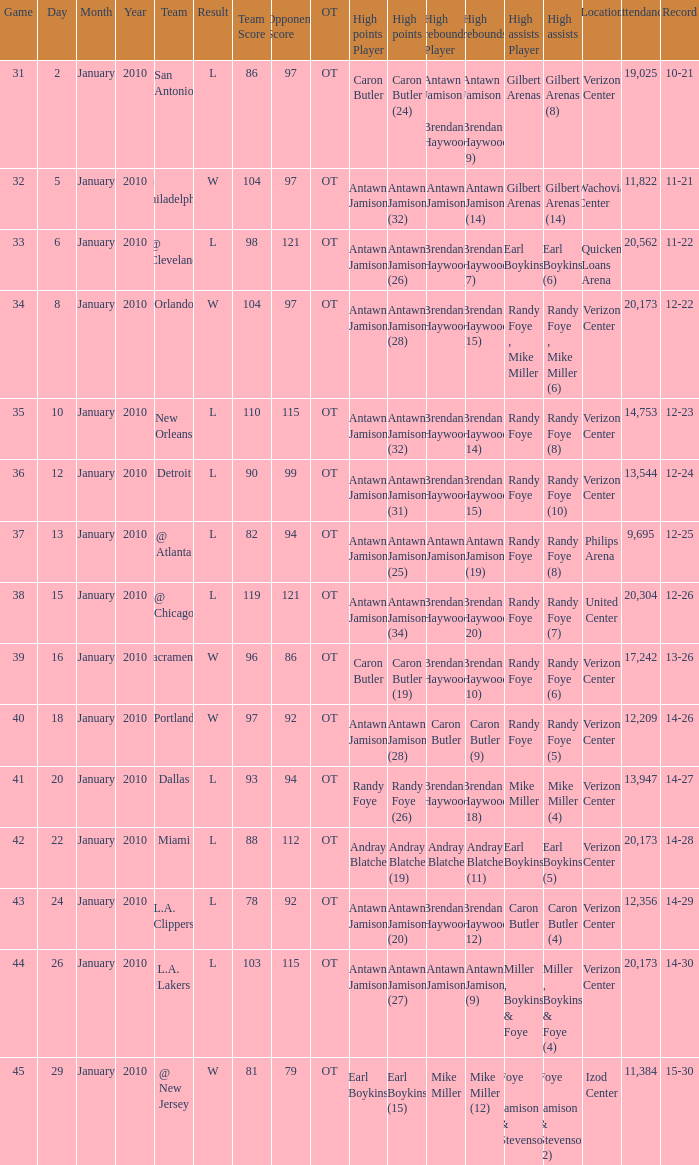How many people got high points in game 35? 1.0. 